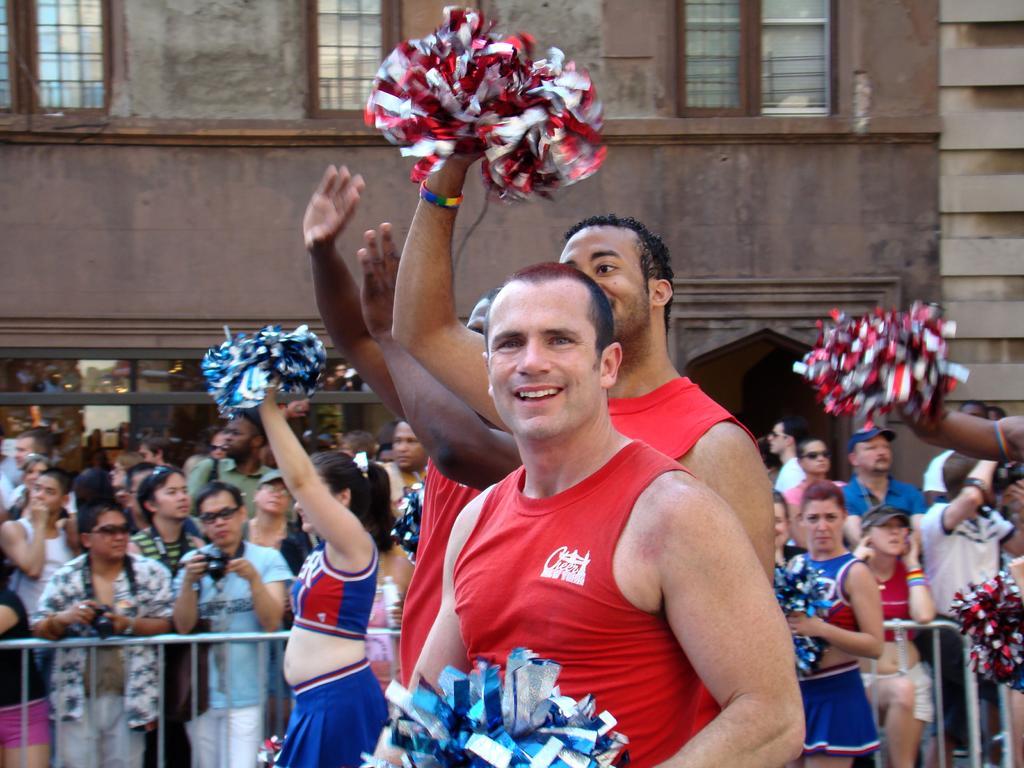Could you give a brief overview of what you see in this image? In this picture I can see there are few men standing and they are holding red and blue papers in their hands and in the backdrop there are few women, they are also holding blue and red color papers and in the backdrop there is a fence and there are few people standing and they are wearing goggles and hand bags. There is a building in the backdrop and there are windows. 